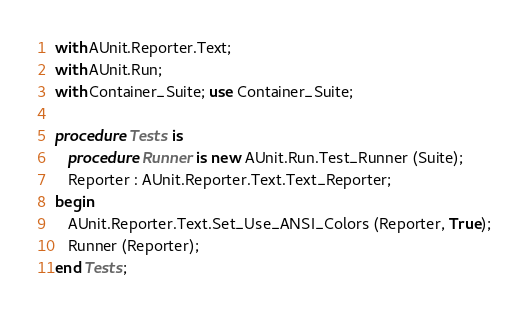Convert code to text. <code><loc_0><loc_0><loc_500><loc_500><_Ada_>with AUnit.Reporter.Text;
with AUnit.Run;
with Container_Suite; use Container_Suite;

procedure Tests is
   procedure Runner is new AUnit.Run.Test_Runner (Suite);
   Reporter : AUnit.Reporter.Text.Text_Reporter;
begin
   AUnit.Reporter.Text.Set_Use_ANSI_Colors (Reporter, True);
   Runner (Reporter);
end Tests;
</code> 